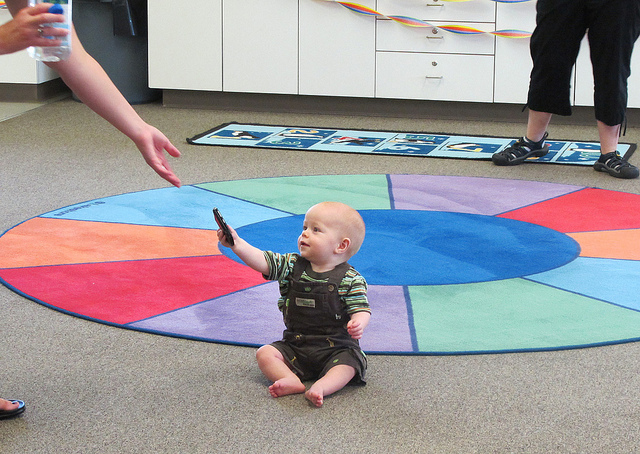Please extract the text content from this image. T G 